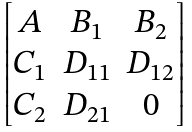<formula> <loc_0><loc_0><loc_500><loc_500>\begin{bmatrix} A & B _ { 1 } & B _ { 2 } \\ C _ { 1 } & D _ { 1 1 } & D _ { 1 2 } \\ C _ { 2 } & D _ { 2 1 } & 0 \end{bmatrix}</formula> 